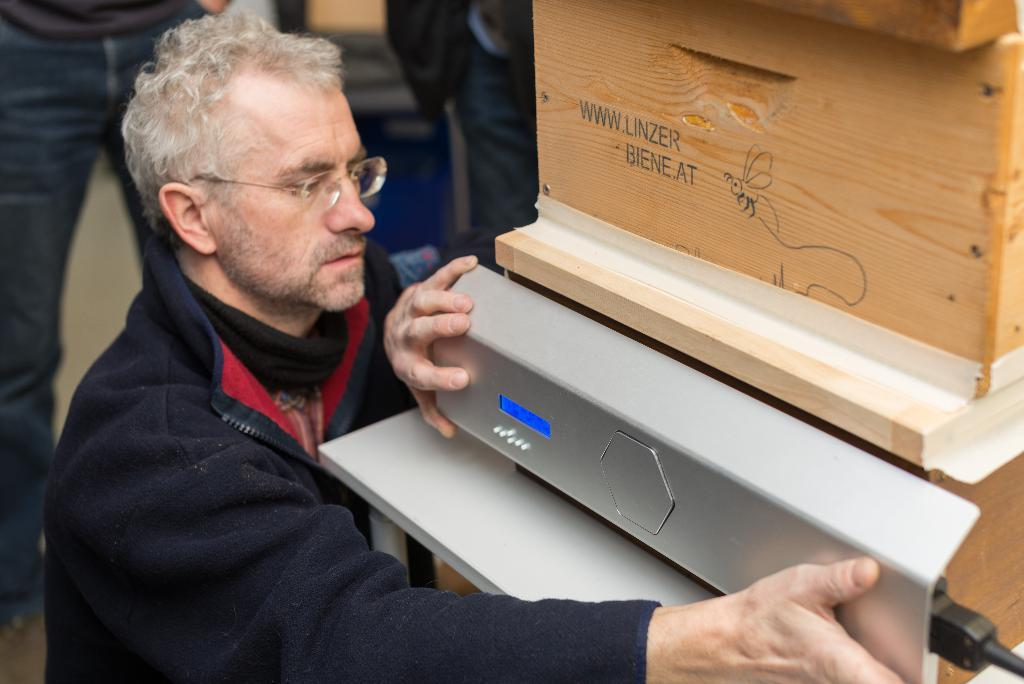Who is present in the image? There is a man in the image. What is the man doing in the image? The man is holding an object in his hands. What can be seen on the table in the image? There is a wooden object on the table. What is visible in the background of the image? There are people and objects in the background of the image. How many girls are visible in the image? There is no mention of girls in the image; only a man and people in the background are present. What type of sign is the man holding in the image? The man is not holding a sign in the image; he is holding an object, but it is not specified as a sign. 